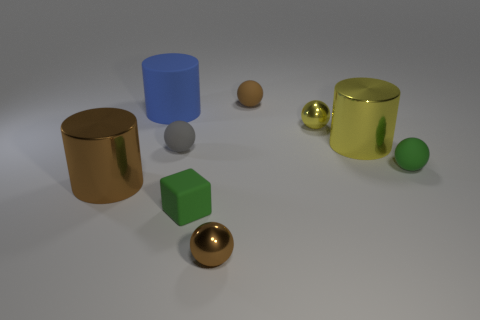Subtract all green balls. How many balls are left? 4 Subtract all green balls. How many balls are left? 4 Subtract all blue balls. Subtract all yellow cylinders. How many balls are left? 5 Add 1 yellow things. How many objects exist? 10 Subtract all cubes. How many objects are left? 8 Add 6 yellow things. How many yellow things are left? 8 Add 5 big brown cylinders. How many big brown cylinders exist? 6 Subtract 0 purple cubes. How many objects are left? 9 Subtract all tiny cylinders. Subtract all tiny brown matte things. How many objects are left? 8 